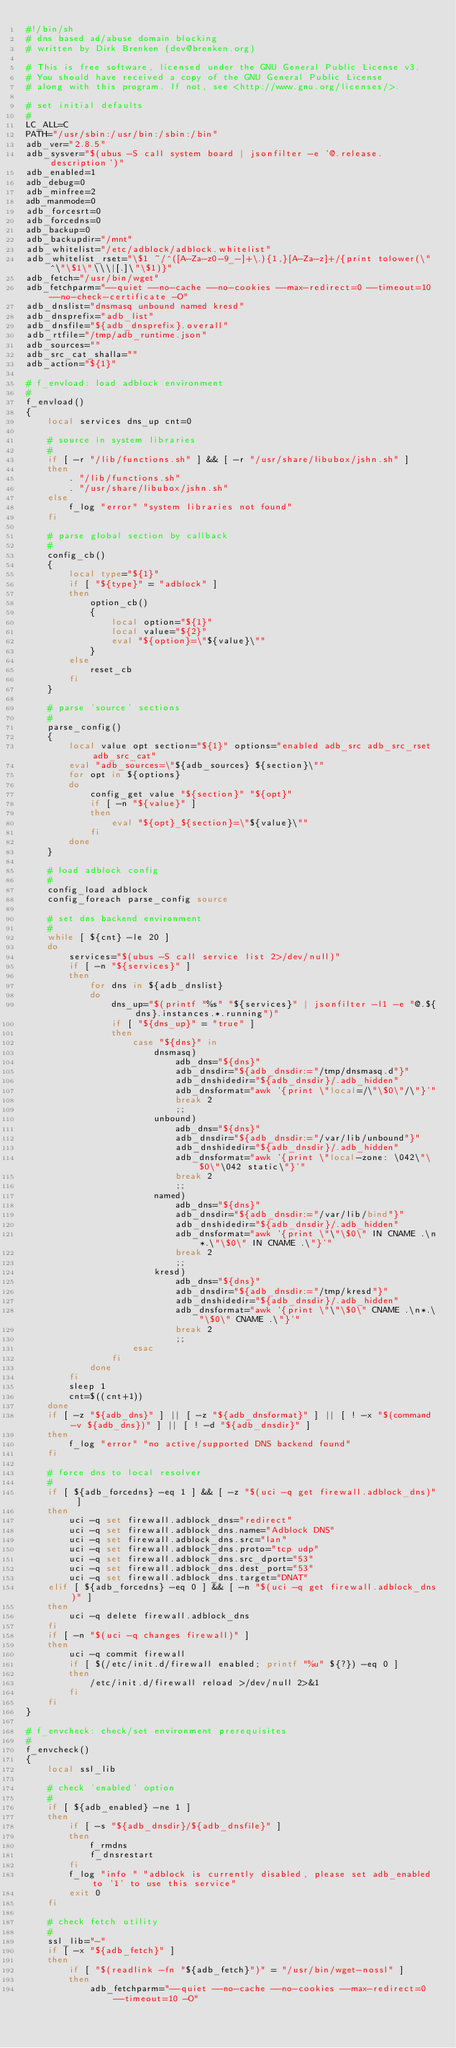Convert code to text. <code><loc_0><loc_0><loc_500><loc_500><_Bash_>#!/bin/sh
# dns based ad/abuse domain blocking
# written by Dirk Brenken (dev@brenken.org)

# This is free software, licensed under the GNU General Public License v3.
# You should have received a copy of the GNU General Public License
# along with this program. If not, see <http://www.gnu.org/licenses/>.

# set initial defaults
#
LC_ALL=C
PATH="/usr/sbin:/usr/bin:/sbin:/bin"
adb_ver="2.8.5"
adb_sysver="$(ubus -S call system board | jsonfilter -e '@.release.description')"
adb_enabled=1
adb_debug=0
adb_minfree=2
adb_manmode=0
adb_forcesrt=0
adb_forcedns=0
adb_backup=0
adb_backupdir="/mnt"
adb_whitelist="/etc/adblock/adblock.whitelist"
adb_whitelist_rset="\$1 ~/^([A-Za-z0-9_-]+\.){1,}[A-Za-z]+/{print tolower(\"^\"\$1\"\\\|[.]\"\$1)}"
adb_fetch="/usr/bin/wget"
adb_fetchparm="--quiet --no-cache --no-cookies --max-redirect=0 --timeout=10 --no-check-certificate -O"
adb_dnslist="dnsmasq unbound named kresd"
adb_dnsprefix="adb_list"
adb_dnsfile="${adb_dnsprefix}.overall"
adb_rtfile="/tmp/adb_runtime.json"
adb_sources=""
adb_src_cat_shalla=""
adb_action="${1}"

# f_envload: load adblock environment
#
f_envload()
{
    local services dns_up cnt=0

    # source in system libraries
    #
    if [ -r "/lib/functions.sh" ] && [ -r "/usr/share/libubox/jshn.sh" ]
    then
        . "/lib/functions.sh"
        . "/usr/share/libubox/jshn.sh"
    else
        f_log "error" "system libraries not found"
    fi

    # parse global section by callback
    #
    config_cb()
    {
        local type="${1}"
        if [ "${type}" = "adblock" ]
        then
            option_cb()
            {
                local option="${1}"
                local value="${2}"
                eval "${option}=\"${value}\""
            }
        else
            reset_cb
        fi
    }

    # parse 'source' sections
    #
    parse_config()
    {
        local value opt section="${1}" options="enabled adb_src adb_src_rset adb_src_cat"
        eval "adb_sources=\"${adb_sources} ${section}\""
        for opt in ${options}
        do
            config_get value "${section}" "${opt}"
            if [ -n "${value}" ]
            then
                eval "${opt}_${section}=\"${value}\""
            fi
        done
    }

    # load adblock config
    #
    config_load adblock
    config_foreach parse_config source

    # set dns backend environment
    #
    while [ ${cnt} -le 20 ]
    do
        services="$(ubus -S call service list 2>/dev/null)"
        if [ -n "${services}" ]
        then
            for dns in ${adb_dnslist}
            do
                dns_up="$(printf "%s" "${services}" | jsonfilter -l1 -e "@.${dns}.instances.*.running")"
                if [ "${dns_up}" = "true" ]
                then
                    case "${dns}" in
                        dnsmasq)
                            adb_dns="${dns}"
                            adb_dnsdir="${adb_dnsdir:="/tmp/dnsmasq.d"}"
                            adb_dnshidedir="${adb_dnsdir}/.adb_hidden"
                            adb_dnsformat="awk '{print \"local=/\"\$0\"/\"}'"
                            break 2
                            ;;
                        unbound)
                            adb_dns="${dns}"
                            adb_dnsdir="${adb_dnsdir:="/var/lib/unbound"}"
                            adb_dnshidedir="${adb_dnsdir}/.adb_hidden"
                            adb_dnsformat="awk '{print \"local-zone: \042\"\$0\"\042 static\"}'"
                            break 2
                            ;;
                        named)
                            adb_dns="${dns}"
                            adb_dnsdir="${adb_dnsdir:="/var/lib/bind"}"
                            adb_dnshidedir="${adb_dnsdir}/.adb_hidden"
                            adb_dnsformat="awk '{print \"\"\$0\" IN CNAME .\n*.\"\$0\" IN CNAME .\"}'"
                            break 2
                            ;;
                        kresd)
                            adb_dns="${dns}"
                            adb_dnsdir="${adb_dnsdir:="/tmp/kresd"}"
                            adb_dnshidedir="${adb_dnsdir}/.adb_hidden"
                            adb_dnsformat="awk '{print \"\"\$0\" CNAME .\n*.\"\$0\" CNAME .\"}'"
                            break 2
                            ;;
                    esac
                fi
            done
        fi
        sleep 1
        cnt=$((cnt+1))
    done
    if [ -z "${adb_dns}" ] || [ -z "${adb_dnsformat}" ] || [ ! -x "$(command -v ${adb_dns})" ] || [ ! -d "${adb_dnsdir}" ]
    then
        f_log "error" "no active/supported DNS backend found"
    fi

    # force dns to local resolver
    #
    if [ ${adb_forcedns} -eq 1 ] && [ -z "$(uci -q get firewall.adblock_dns)" ]
    then
        uci -q set firewall.adblock_dns="redirect"
        uci -q set firewall.adblock_dns.name="Adblock DNS"
        uci -q set firewall.adblock_dns.src="lan"
        uci -q set firewall.adblock_dns.proto="tcp udp"
        uci -q set firewall.adblock_dns.src_dport="53"
        uci -q set firewall.adblock_dns.dest_port="53"
        uci -q set firewall.adblock_dns.target="DNAT"
    elif [ ${adb_forcedns} -eq 0 ] && [ -n "$(uci -q get firewall.adblock_dns)" ]
    then
        uci -q delete firewall.adblock_dns
    fi
    if [ -n "$(uci -q changes firewall)" ]
    then
        uci -q commit firewall
        if [ $(/etc/init.d/firewall enabled; printf "%u" ${?}) -eq 0 ]
        then
            /etc/init.d/firewall reload >/dev/null 2>&1
        fi
    fi
}

# f_envcheck: check/set environment prerequisites
#
f_envcheck()
{
    local ssl_lib

    # check 'enabled' option
    #
    if [ ${adb_enabled} -ne 1 ]
    then
        if [ -s "${adb_dnsdir}/${adb_dnsfile}" ]
        then
            f_rmdns
            f_dnsrestart
        fi
        f_log "info " "adblock is currently disabled, please set adb_enabled to '1' to use this service"
        exit 0
    fi

    # check fetch utility
    #
    ssl_lib="-"
    if [ -x "${adb_fetch}" ]
    then
        if [ "$(readlink -fn "${adb_fetch}")" = "/usr/bin/wget-nossl" ]
        then
            adb_fetchparm="--quiet --no-cache --no-cookies --max-redirect=0 --timeout=10 -O"</code> 